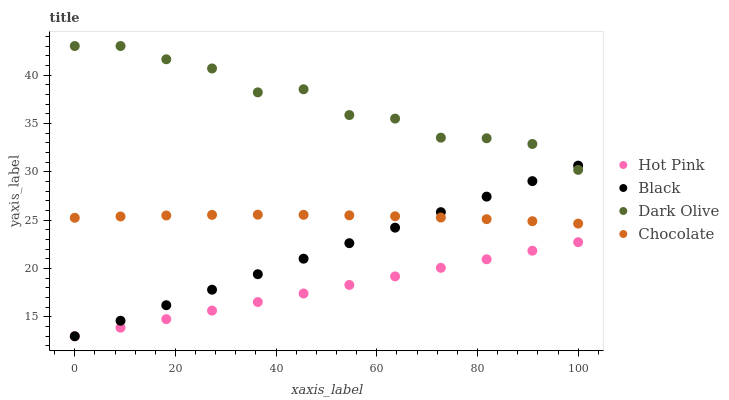Does Hot Pink have the minimum area under the curve?
Answer yes or no. Yes. Does Dark Olive have the maximum area under the curve?
Answer yes or no. Yes. Does Black have the minimum area under the curve?
Answer yes or no. No. Does Black have the maximum area under the curve?
Answer yes or no. No. Is Hot Pink the smoothest?
Answer yes or no. Yes. Is Dark Olive the roughest?
Answer yes or no. Yes. Is Black the smoothest?
Answer yes or no. No. Is Black the roughest?
Answer yes or no. No. Does Hot Pink have the lowest value?
Answer yes or no. Yes. Does Chocolate have the lowest value?
Answer yes or no. No. Does Dark Olive have the highest value?
Answer yes or no. Yes. Does Black have the highest value?
Answer yes or no. No. Is Hot Pink less than Dark Olive?
Answer yes or no. Yes. Is Chocolate greater than Hot Pink?
Answer yes or no. Yes. Does Hot Pink intersect Black?
Answer yes or no. Yes. Is Hot Pink less than Black?
Answer yes or no. No. Is Hot Pink greater than Black?
Answer yes or no. No. Does Hot Pink intersect Dark Olive?
Answer yes or no. No. 